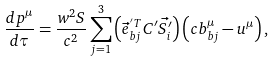<formula> <loc_0><loc_0><loc_500><loc_500>\frac { d p ^ { \mu } } { d \tau } = \frac { w ^ { 2 } S } { c ^ { 2 } } \sum _ { j = 1 } ^ { 3 } \left ( \vec { e } ^ { ^ { \prime } T } _ { b j } C ^ { \prime } \vec { S ^ { \prime } _ { i } } \right ) \left ( c b _ { b j } ^ { \mu } - u ^ { \mu } \right ) ,</formula> 